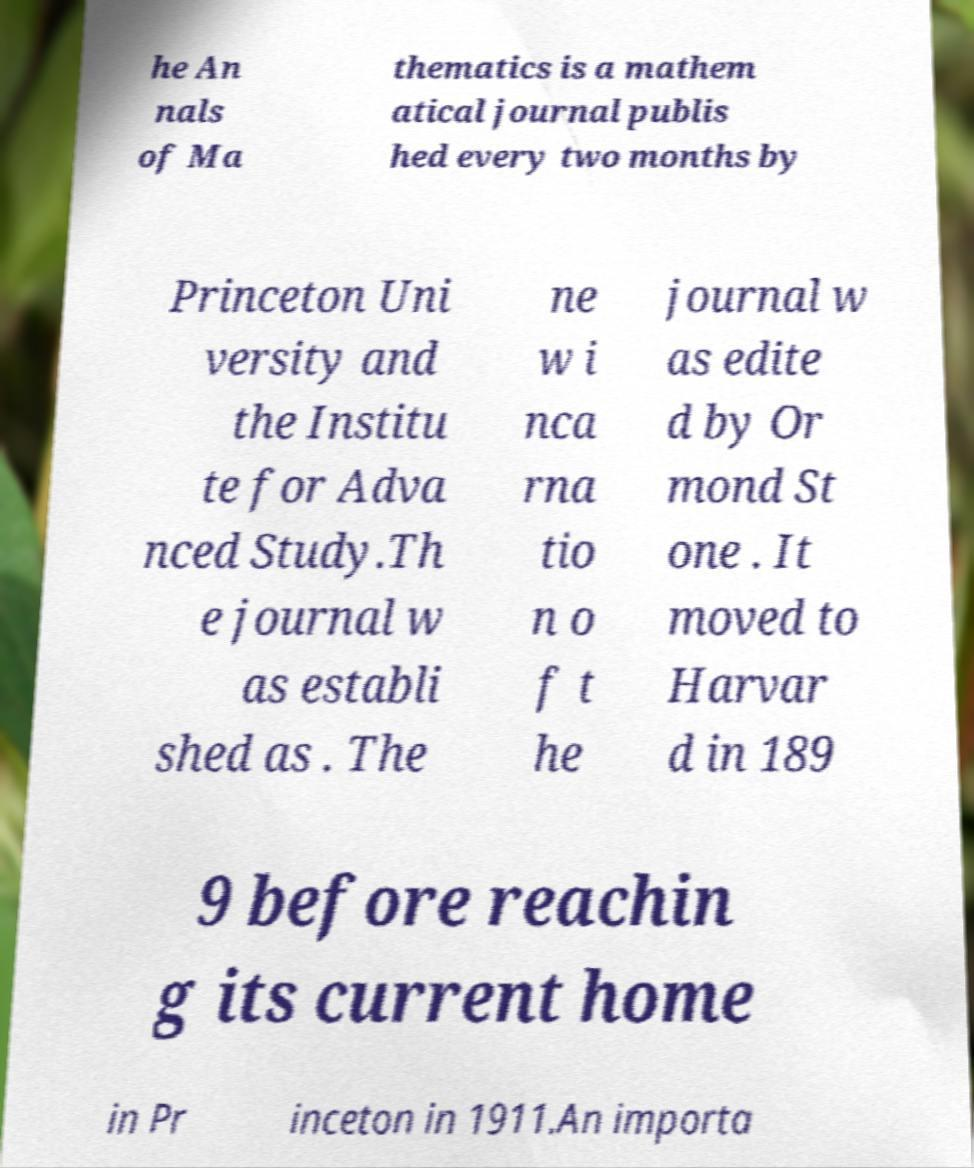Please read and relay the text visible in this image. What does it say? he An nals of Ma thematics is a mathem atical journal publis hed every two months by Princeton Uni versity and the Institu te for Adva nced Study.Th e journal w as establi shed as . The ne w i nca rna tio n o f t he journal w as edite d by Or mond St one . It moved to Harvar d in 189 9 before reachin g its current home in Pr inceton in 1911.An importa 